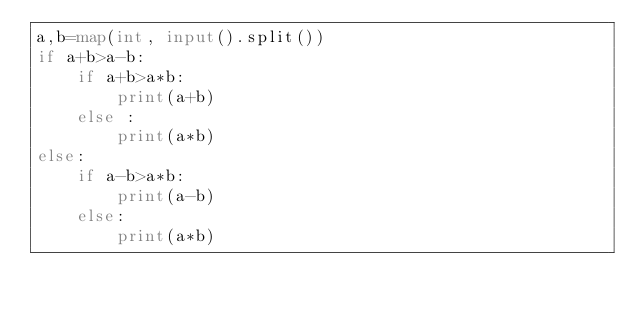<code> <loc_0><loc_0><loc_500><loc_500><_Python_>a,b=map(int, input().split())
if a+b>a-b:
    if a+b>a*b:
        print(a+b)
    else :
        print(a*b)
else:
    if a-b>a*b:
        print(a-b)
    else:
        print(a*b)</code> 